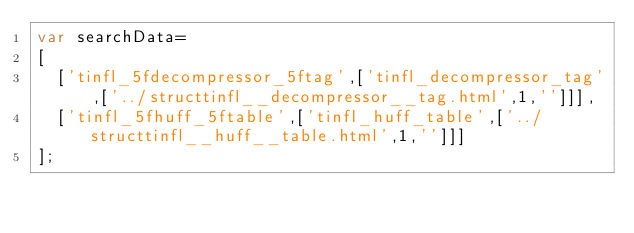Convert code to text. <code><loc_0><loc_0><loc_500><loc_500><_JavaScript_>var searchData=
[
  ['tinfl_5fdecompressor_5ftag',['tinfl_decompressor_tag',['../structtinfl__decompressor__tag.html',1,'']]],
  ['tinfl_5fhuff_5ftable',['tinfl_huff_table',['../structtinfl__huff__table.html',1,'']]]
];
</code> 